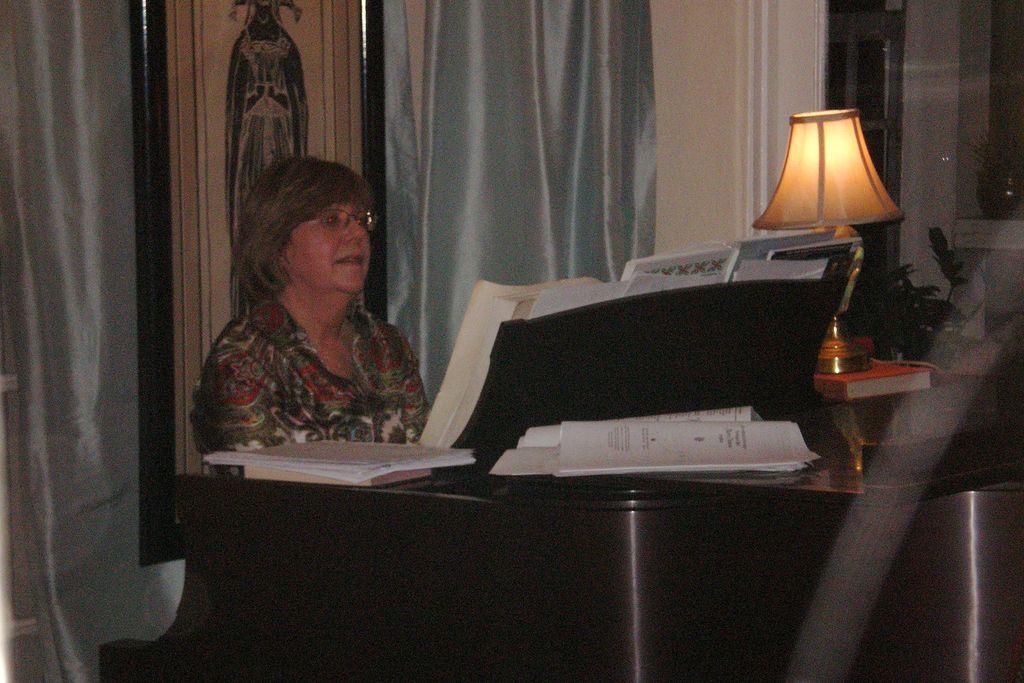Please provide a concise description of this image. In the image we can see there is a woman sitting on the piano and there is table lamp kept on the book and there is curtain on the window. 